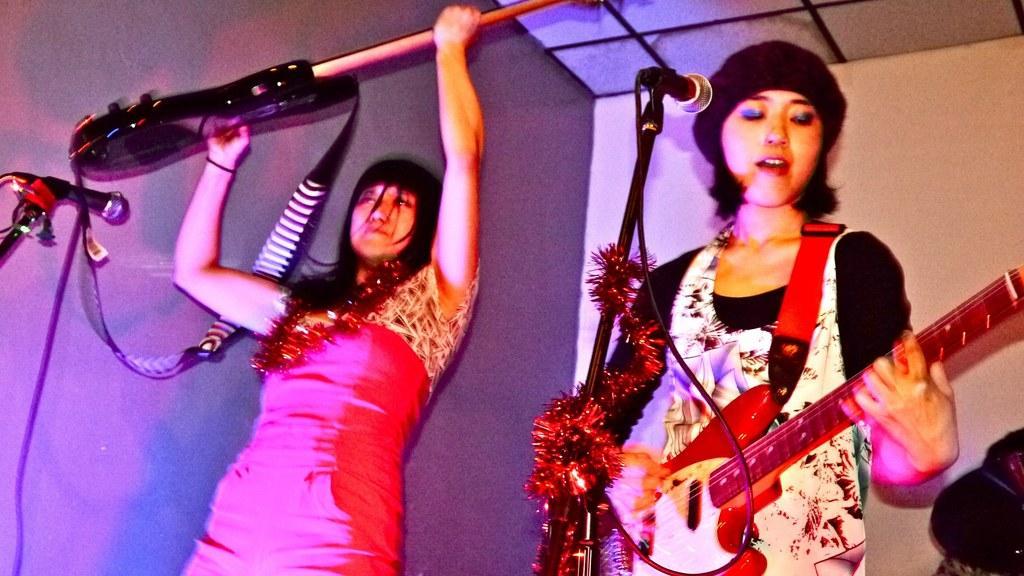How would you summarize this image in a sentence or two? in the picture there are two women holding guitar and singing songs in a micro phone which is in front of him. 